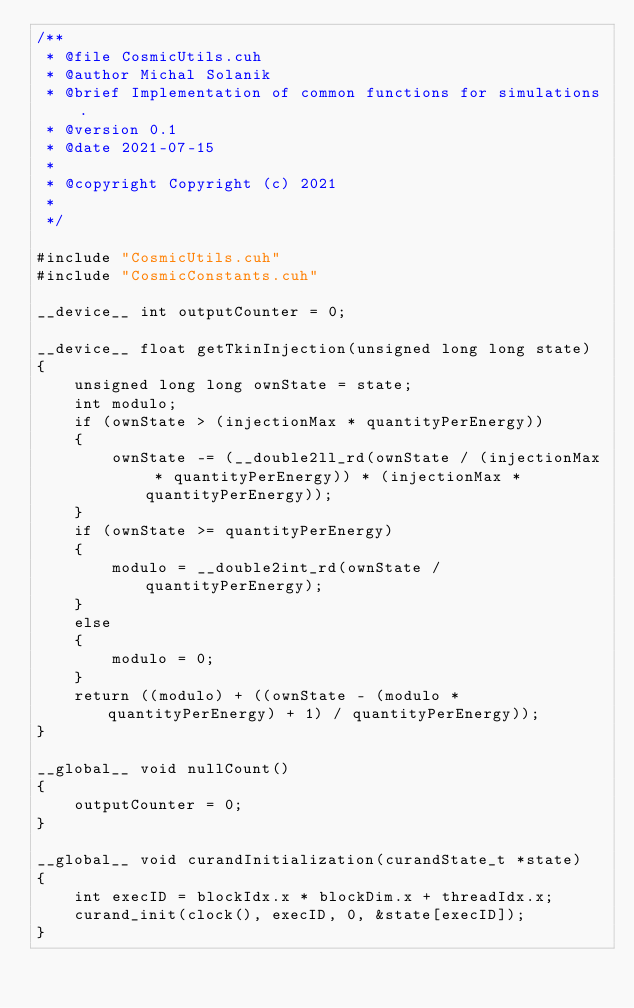Convert code to text. <code><loc_0><loc_0><loc_500><loc_500><_Cuda_>/**
 * @file CosmicUtils.cuh
 * @author Michal Solanik
 * @brief Implementation of common functions for simulations.
 * @version 0.1
 * @date 2021-07-15
 * 
 * @copyright Copyright (c) 2021
 * 
 */

#include "CosmicUtils.cuh"
#include "CosmicConstants.cuh"

__device__ int outputCounter = 0;

__device__ float getTkinInjection(unsigned long long state)
{
	unsigned long long ownState = state;
	int modulo;
	if (ownState > (injectionMax * quantityPerEnergy))
	{
		ownState -= (__double2ll_rd(ownState / (injectionMax * quantityPerEnergy)) * (injectionMax * quantityPerEnergy));
	}
	if (ownState >= quantityPerEnergy)
	{
		modulo = __double2int_rd(ownState / quantityPerEnergy);
	}
	else
	{
		modulo = 0;
	}
	return ((modulo) + ((ownState - (modulo * quantityPerEnergy) + 1) / quantityPerEnergy));
}

__global__ void nullCount()
{
	outputCounter = 0;
}

__global__ void curandInitialization(curandState_t *state)
{
	int execID = blockIdx.x * blockDim.x + threadIdx.x;
	curand_init(clock(), execID, 0, &state[execID]);
}</code> 